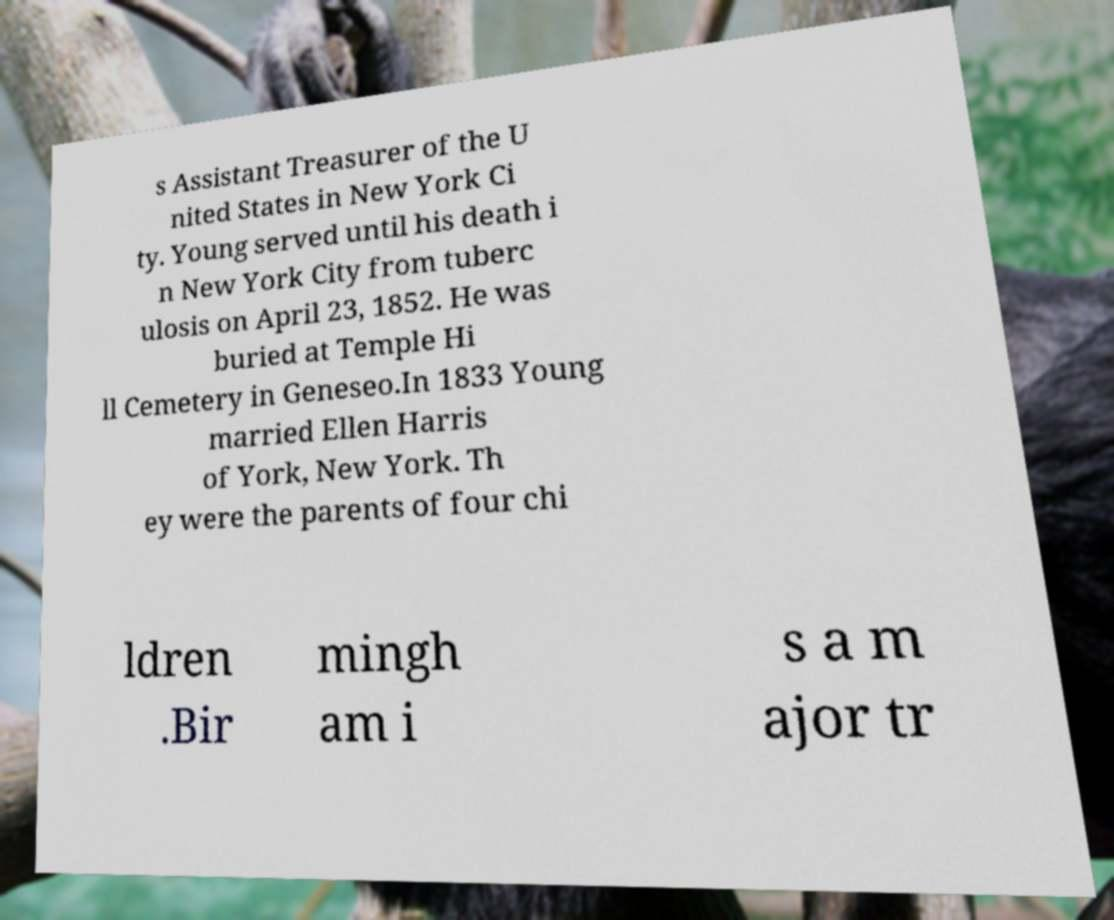Can you accurately transcribe the text from the provided image for me? s Assistant Treasurer of the U nited States in New York Ci ty. Young served until his death i n New York City from tuberc ulosis on April 23, 1852. He was buried at Temple Hi ll Cemetery in Geneseo.In 1833 Young married Ellen Harris of York, New York. Th ey were the parents of four chi ldren .Bir mingh am i s a m ajor tr 